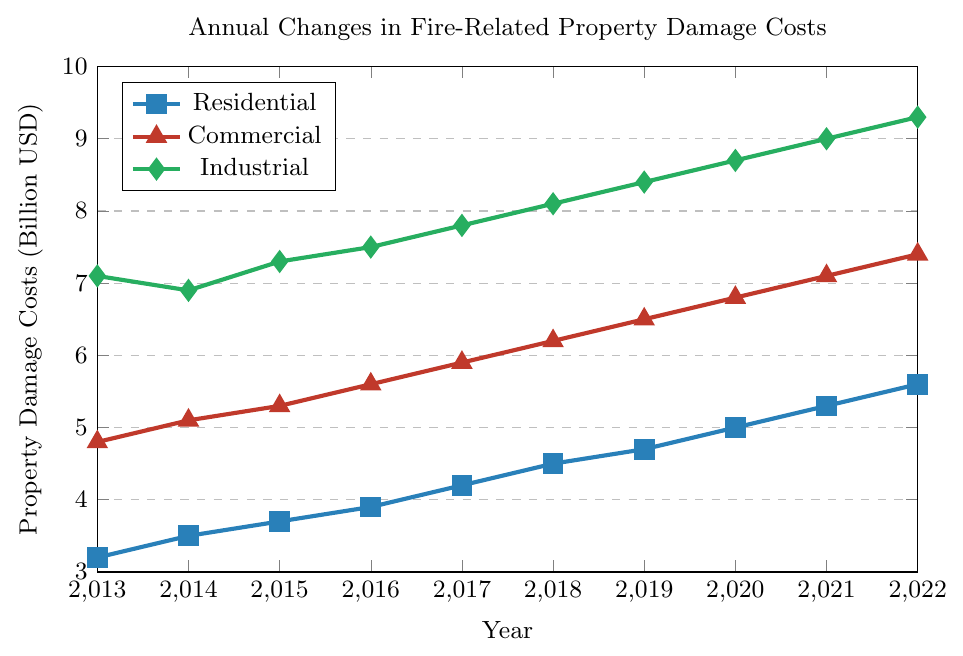What was the property damage cost for residential properties in 2018? Look at the point corresponding to 2018 for the residential line, which is blue and marked with a square. The y-value of this point is 4.5 billion USD
Answer: 4.5 billion USD Which sector had the highest property damage cost in 2013? Compare the y-values of the three sectors at 2013. The residential sector is 3.2 billion USD, the commercial sector is 4.8 billion USD, and the industrial sector is 7.1 billion USD. The highest is the industrial sector
Answer: Industrial By how much did the residential property damage costs increase from 2013 to 2022? Find the y-values for residential in 2013 and 2022, which are 3.2 billion USD and 5.6 billion USD. Subtract the 2013 value from the 2022 value: 5.6 - 3.2 = 2.4
Answer: 2.4 billion USD Which sector showed the most consistent increase in property damage costs over the years? Compare the trends of the lines for all three sectors. The residential sector consistently rises without any dips, while the commercial and industrial sectors have periods of fluctuation or leveling off
Answer: Residential In which year did the commercial sector exceed 6 billion USD in property damage costs for the first time? Examine the y-values for the commercial sector and see which year first surpasses 6 billion USD. This occurs at 2018, where the commercial sector reaches 6.2 billion USD.
Answer: 2018 How much did the industrial property damage costs change from 2014 to 2015? Find the y-values for industrial in 2014 and 2015, which are 6.9 billion USD and 7.3 billion USD. Subtract the 2014 value from the 2015 value: 7.3 - 6.9 = 0.4
Answer: 0.4 billion USD What is the average property damage cost for commercial properties over the decade? Sum the y-values of the commercial sector from 2013 to 2022 and divide by 10. (4.8 + 5.1 + 5.3 + 5.6 + 5.9 + 6.2 + 6.5 + 6.8 + 7.1 + 7.4) / 10 = 6.07 billion USD
Answer: 6.07 billion USD Which sector had the smallest increase in property damage costs from 2013 to 2014? Calculate the increase for each sector: Residential: 3.5 - 3.2 = 0.3, Commercial: 5.1 - 4.8 = 0.3, Industrial: 6.9 - 7.1 = -0.2. The smallest increase (actually a decrease) is in the Industrial sector.
Answer: Industrial In what year did the residential property damage costs reach 5 billion USD? Look at the y-values for the residential line and find the year when it reaches 5 billion USD. This occurs in 2020.
Answer: 2020 